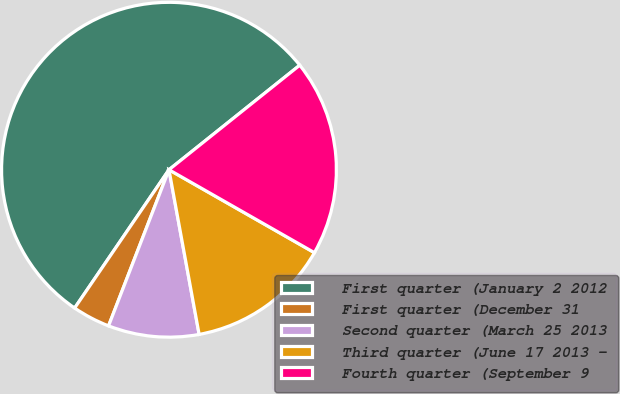Convert chart to OTSL. <chart><loc_0><loc_0><loc_500><loc_500><pie_chart><fcel>First quarter (January 2 2012<fcel>First quarter (December 31<fcel>Second quarter (March 25 2013<fcel>Third quarter (June 17 2013 -<fcel>Fourth quarter (September 9<nl><fcel>54.74%<fcel>3.65%<fcel>8.76%<fcel>13.87%<fcel>18.98%<nl></chart> 